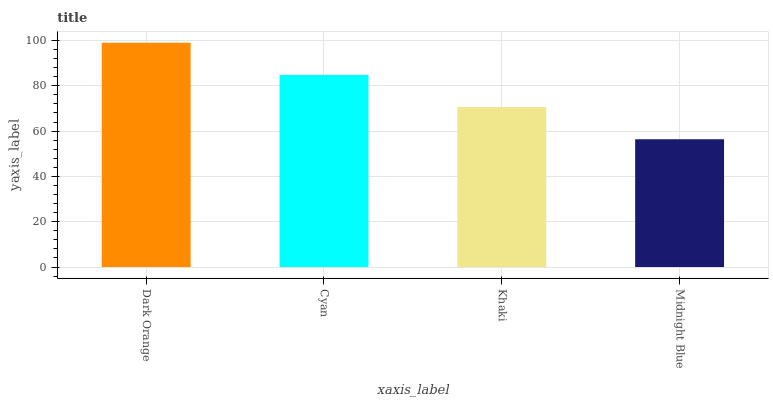Is Midnight Blue the minimum?
Answer yes or no. Yes. Is Dark Orange the maximum?
Answer yes or no. Yes. Is Cyan the minimum?
Answer yes or no. No. Is Cyan the maximum?
Answer yes or no. No. Is Dark Orange greater than Cyan?
Answer yes or no. Yes. Is Cyan less than Dark Orange?
Answer yes or no. Yes. Is Cyan greater than Dark Orange?
Answer yes or no. No. Is Dark Orange less than Cyan?
Answer yes or no. No. Is Cyan the high median?
Answer yes or no. Yes. Is Khaki the low median?
Answer yes or no. Yes. Is Khaki the high median?
Answer yes or no. No. Is Dark Orange the low median?
Answer yes or no. No. 